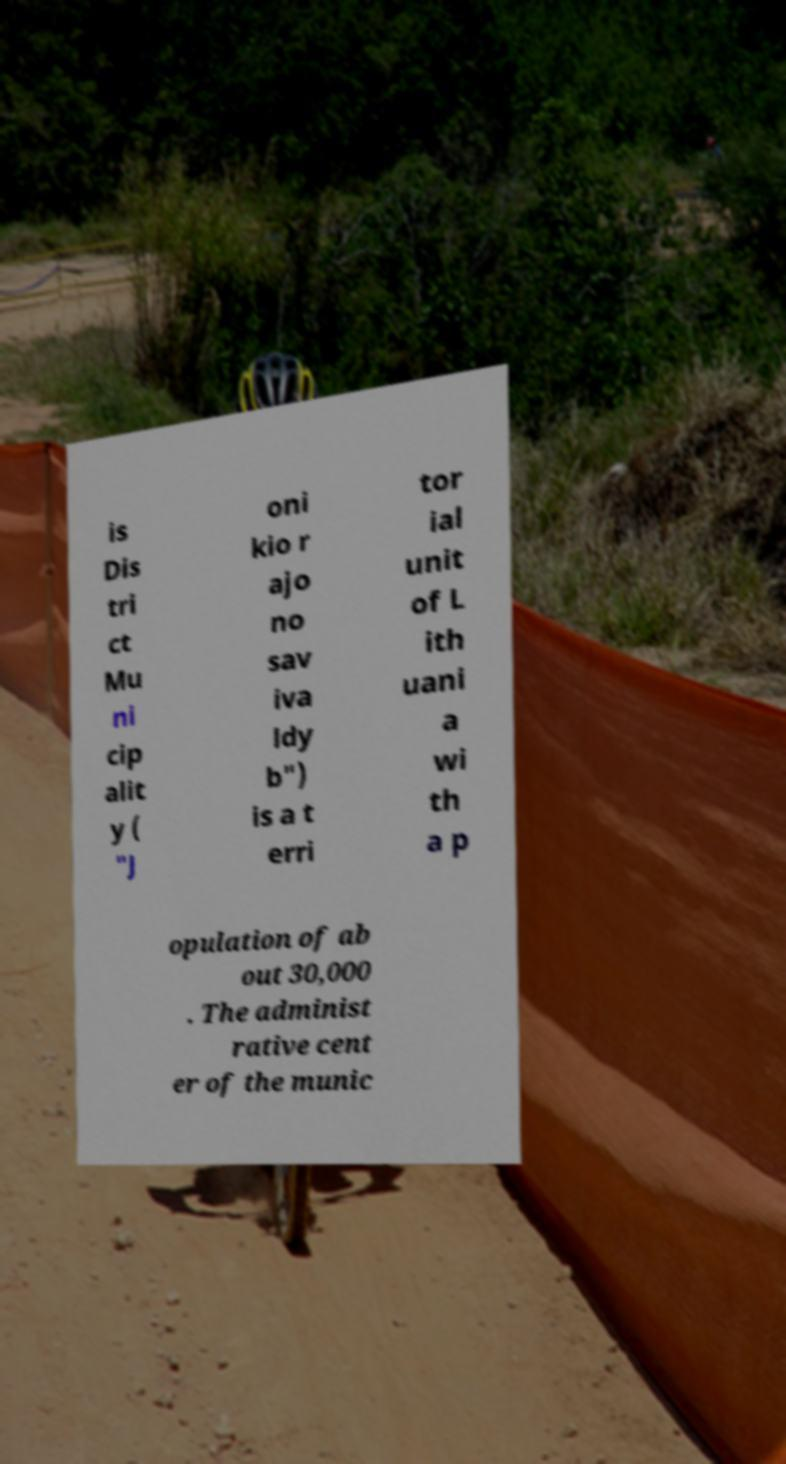Could you extract and type out the text from this image? is Dis tri ct Mu ni cip alit y ( "J oni kio r ajo no sav iva ldy b") is a t erri tor ial unit of L ith uani a wi th a p opulation of ab out 30,000 . The administ rative cent er of the munic 